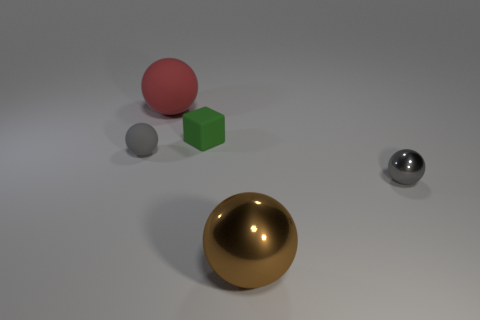Add 3 blocks. How many objects exist? 8 Subtract all brown balls. How many balls are left? 3 Subtract all red balls. How many balls are left? 3 Subtract 0 cyan balls. How many objects are left? 5 Subtract all spheres. How many objects are left? 1 Subtract 1 blocks. How many blocks are left? 0 Subtract all blue cubes. Subtract all purple cylinders. How many cubes are left? 1 Subtract all purple cubes. How many brown spheres are left? 1 Subtract all large shiny objects. Subtract all big matte things. How many objects are left? 3 Add 3 green blocks. How many green blocks are left? 4 